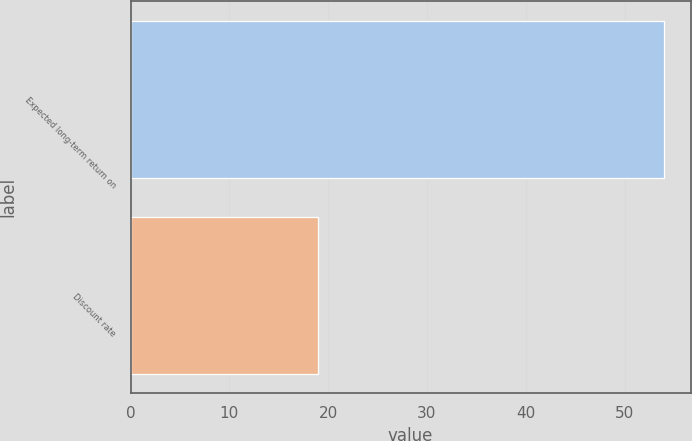Convert chart. <chart><loc_0><loc_0><loc_500><loc_500><bar_chart><fcel>Expected long-term return on<fcel>Discount rate<nl><fcel>54<fcel>19<nl></chart> 